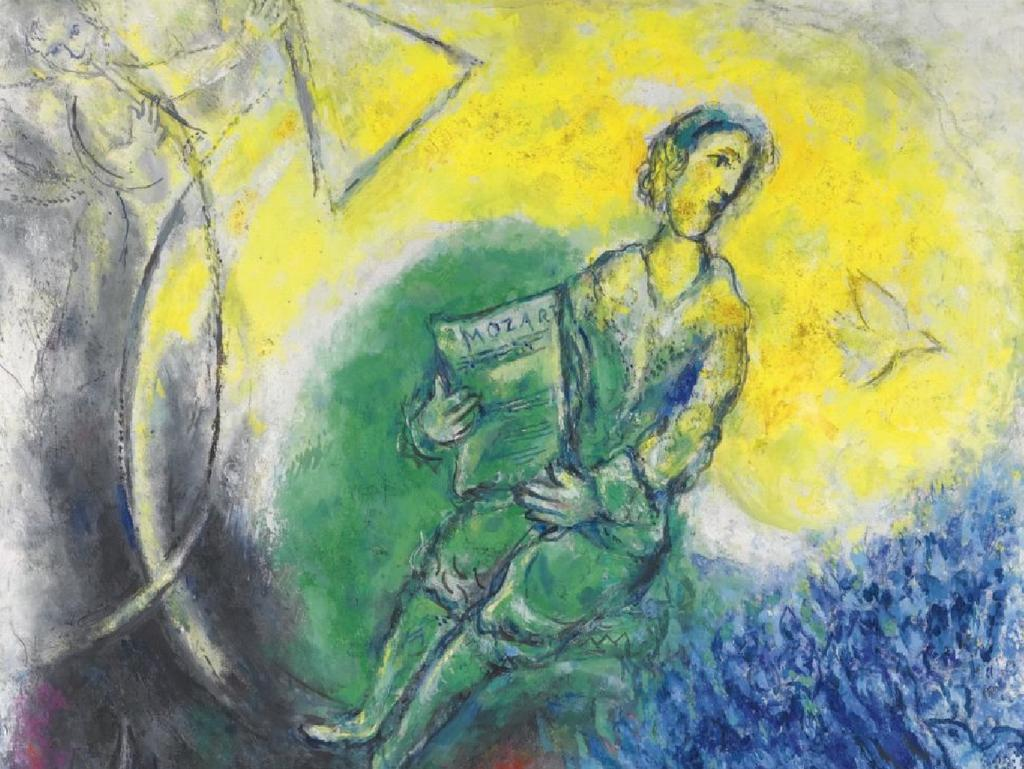What is the main subject of the painting in the image? The main subject of the painting in the image is a person. How many giants are depicted in the painting? There are no giants depicted in the painting; it features a person. What type of cracker is being used as a prop in the painting? There is no cracker present in the painting; it features a person. 